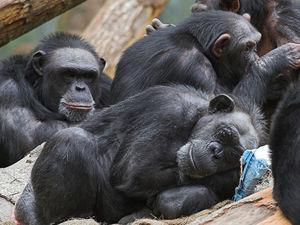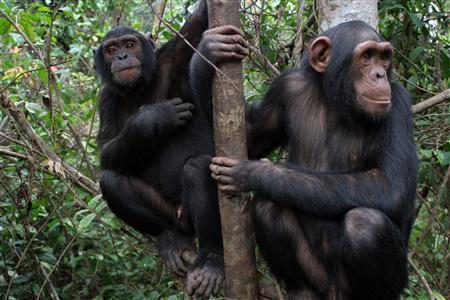The first image is the image on the left, the second image is the image on the right. Examine the images to the left and right. Is the description "One chimp has a wide open mouth showing its front row of teeth." accurate? Answer yes or no. No. The first image is the image on the left, the second image is the image on the right. Assess this claim about the two images: "One of the animals in the image on the left has its teeth exposed.". Correct or not? Answer yes or no. No. 